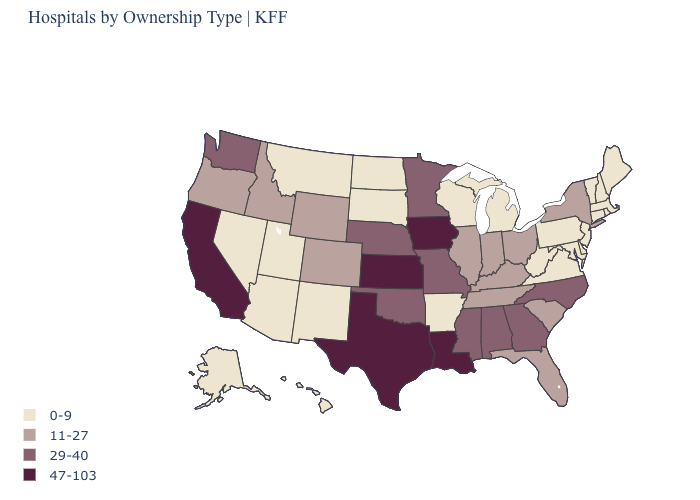What is the value of Washington?
Give a very brief answer. 29-40. Among the states that border Texas , which have the highest value?
Concise answer only. Louisiana. How many symbols are there in the legend?
Write a very short answer. 4. Which states have the highest value in the USA?
Keep it brief. California, Iowa, Kansas, Louisiana, Texas. Which states hav the highest value in the South?
Be succinct. Louisiana, Texas. Name the states that have a value in the range 11-27?
Be succinct. Colorado, Florida, Idaho, Illinois, Indiana, Kentucky, New York, Ohio, Oregon, South Carolina, Tennessee, Wyoming. Name the states that have a value in the range 29-40?
Write a very short answer. Alabama, Georgia, Minnesota, Mississippi, Missouri, Nebraska, North Carolina, Oklahoma, Washington. Is the legend a continuous bar?
Write a very short answer. No. Does Texas have the highest value in the USA?
Give a very brief answer. Yes. How many symbols are there in the legend?
Answer briefly. 4. Among the states that border Kansas , which have the highest value?
Keep it brief. Missouri, Nebraska, Oklahoma. Among the states that border Colorado , does Kansas have the highest value?
Quick response, please. Yes. What is the value of Ohio?
Keep it brief. 11-27. Does the first symbol in the legend represent the smallest category?
Give a very brief answer. Yes. Does South Carolina have a lower value than Minnesota?
Concise answer only. Yes. 